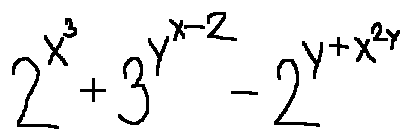<formula> <loc_0><loc_0><loc_500><loc_500>2 ^ { x ^ { 3 } } + 3 ^ { y ^ { x - 2 } } - 2 ^ { y + x ^ { 2 y } }</formula> 